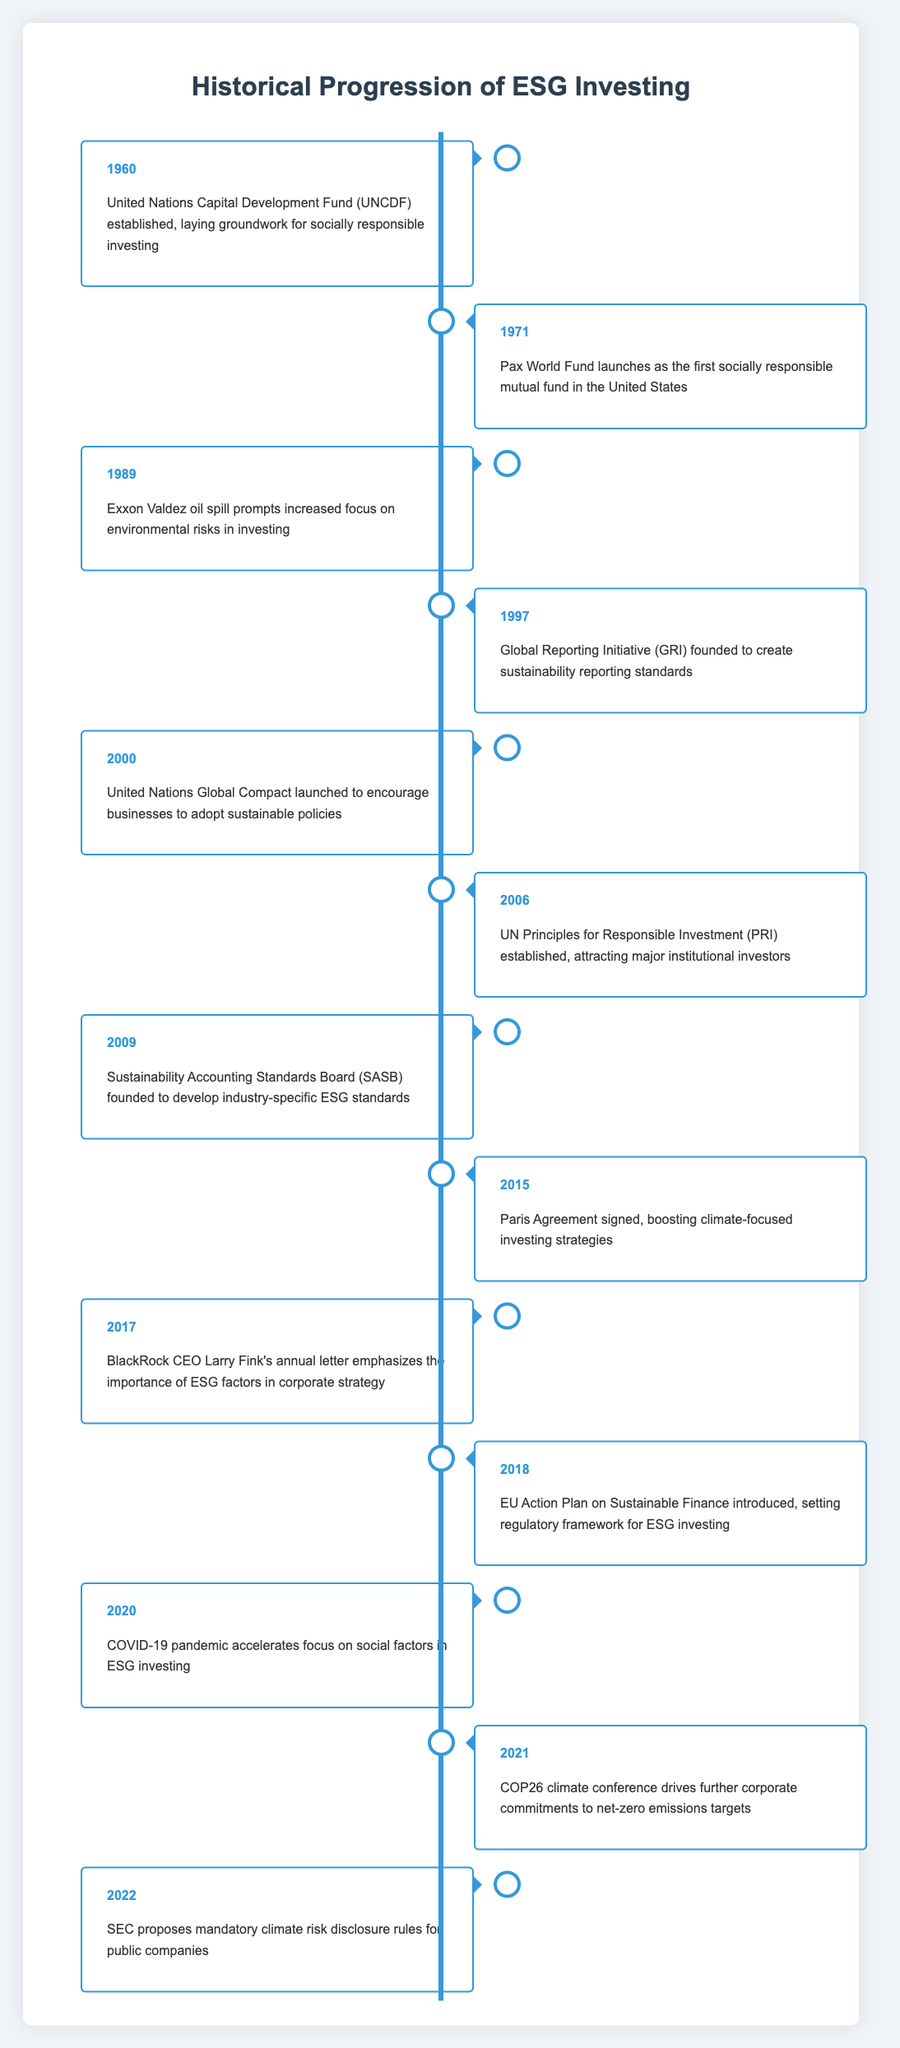What was the first socially responsible mutual fund launched in the United States? The table states that the Pax World Fund was launched in 1971 as the first socially responsible mutual fund in the United States.
Answer: Pax World Fund Which year marked the establishment of the United Nations Global Compact? According to the timeline, the United Nations Global Compact was launched in the year 2000.
Answer: 2000 Was the SEC's proposal for mandatory climate risk disclosure made before or after the COP26 conference? The SEC proposed mandatory climate risk disclosure rules in 2022, while the COP26 climate conference occurred in 2021. Therefore, the SEC's proposal was made after the COP26 event.
Answer: After How many significant events related to ESG investing occurred between 2000 and 2010? The years in that range with events are 2000 (UN Global Compact), 2006 (UN PRI), and 2009 (SASB). This gives us three significant events occurring within that time frame.
Answer: 3 In what year did the Paris Agreement get signed and what impact did it have on investing strategies? The Paris Agreement was signed in 2015, boosting climate-focused investing strategies, as indicated in the timeline.
Answer: 2015 Which event increased focus on environmental risks in investing? The Exxon Valdez oil spill in 1989 prompted the increased focus on environmental risks, according to the table.
Answer: Exxon Valdez oil spill What was the trend in ESG events from the year 2000 to 2022? If we analyze the table, starting from the year 2000 and moving to 2022, we can observe a general increasing trend in significant events related to ESG investing, indicating growing importance over the years.
Answer: Increasing trend What was established in 2006 that attracted major institutional investors? The establishment of the UN Principles for Responsible Investment (PRI) in 2006 attracted major institutional investors, as listed in the timeline.
Answer: UN PRI How many years passed between the establishment of the Global Reporting Initiative and the signing of the Paris Agreement? The Global Reporting Initiative was founded in 1997, and the Paris Agreement was signed in 2015. The difference between these years is 2015 - 1997 = 18 years.
Answer: 18 years 